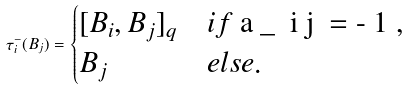<formula> <loc_0><loc_0><loc_500><loc_500>\tau _ { i } ^ { - } ( B _ { j } ) = \begin{cases} [ B _ { i } , B _ { j } ] _ { q } & i f $ a _ { i j } = - 1 $ , \\ B _ { j } & e l s e . \end{cases}</formula> 